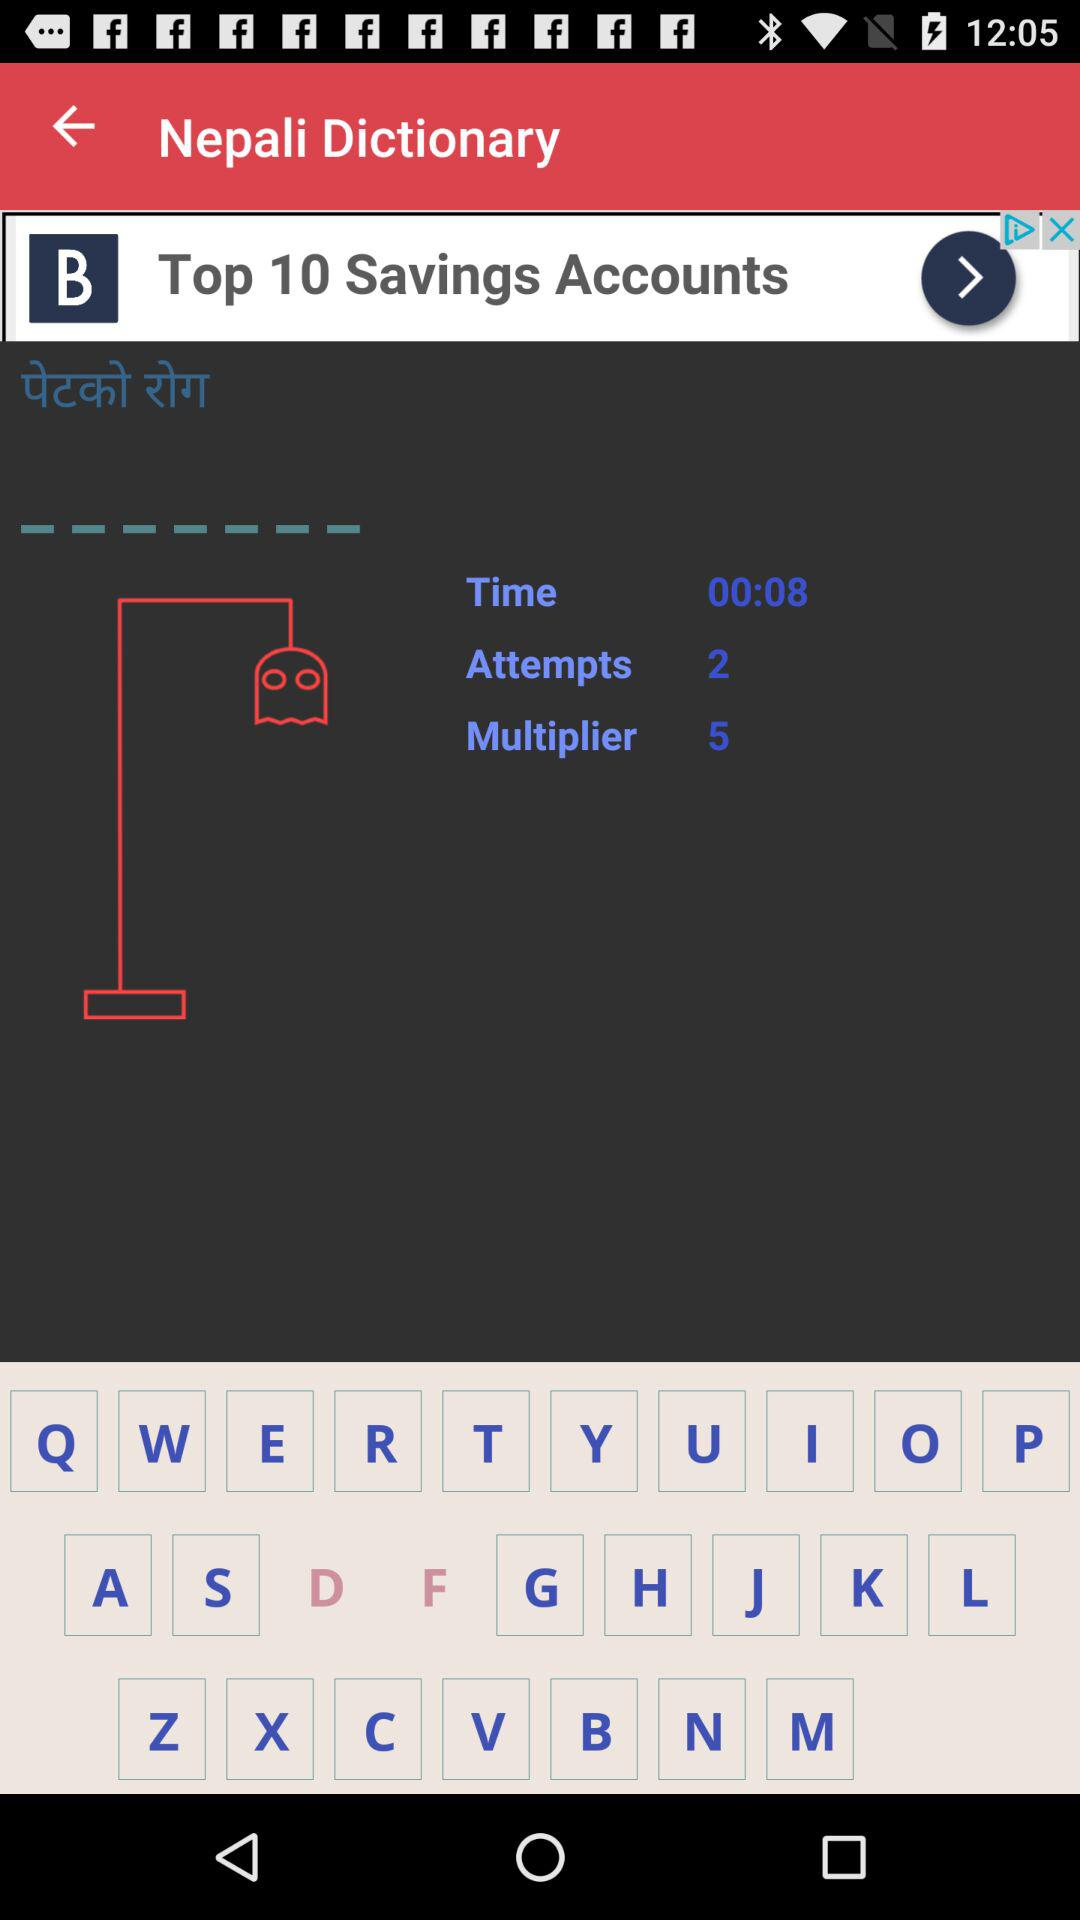How many multipliers are given? There are five multipliers. 